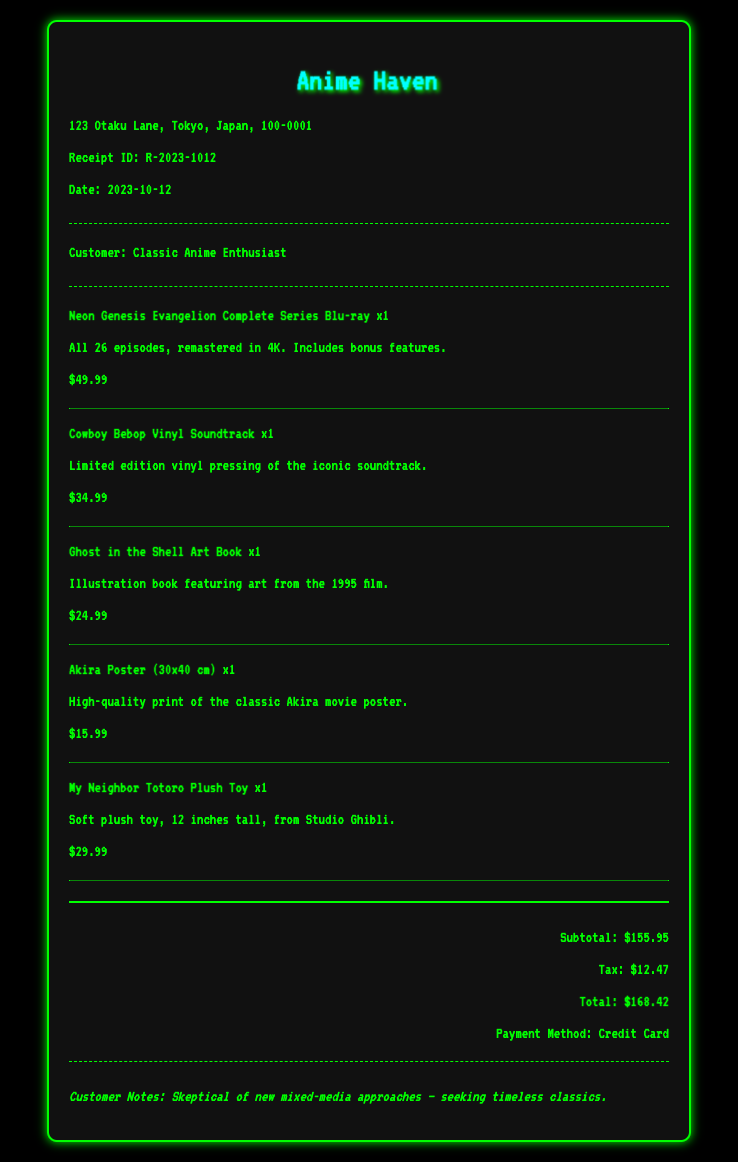what is the receipt ID? The receipt ID is a unique identifier found on the document that helps to reference this particular transaction.
Answer: R-2023-1012 who is the customer? The customer name appears in the customer information section of the document, identifying the person who made the purchase.
Answer: Classic Anime Enthusiast what date is on the receipt? The date specified in the document indicates when the purchase was made or when the receipt was generated.
Answer: 2023-10-12 what is the total amount spent? The total amount is the cumulative cost of all items purchased, including taxes as indicated in the totals section of the document.
Answer: $168.42 how many items were purchased? The total number of distinct items listed in the items section of the document can be counted to ascertain how many separate products were bought.
Answer: 5 what was the subtotal before tax? The subtotal amount shows the total of the items purchased before the addition of any taxes, which is clearly outlined in the totals section.
Answer: $155.95 what was the payment method used? The payment method refers to how the customer chose to pay for the items, which is mentioned in the document.
Answer: Credit Card which item has the highest price? The item with the highest price can be determined by comparing the listed prices of each item in the document.
Answer: Neon Genesis Evangelion Complete Series Blu-ray what is noted in the customer notes section? The customer notes provide insight into the customer's perspective regarding their purchase, as found in the notes section of the document.
Answer: Skeptical of new mixed-media approaches – seeking timeless classics 